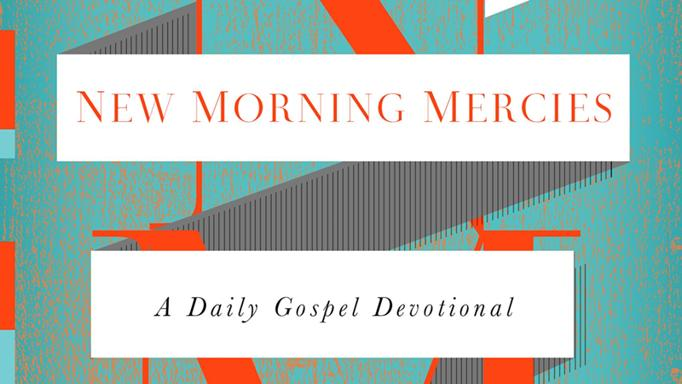Explore the possible themes this devotional might cover based on its visual presentation. The visual presentation, with its vibrant orange and stark white colors, along with dynamic geometric shapes, might suggest themes of energy, rejuvenation, and clarity in spiritual understanding. These elements could indicate that the devotional explores fresh perspectives on gospel truths, intending to invigorate and clarify daily spiritual reflections. 